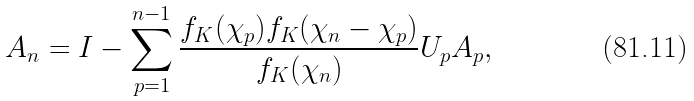Convert formula to latex. <formula><loc_0><loc_0><loc_500><loc_500>A _ { n } = I - \sum _ { p = 1 } ^ { n - 1 } \frac { f _ { K } ( \chi _ { p } ) f _ { K } ( \chi _ { n } - \chi _ { p } ) } { f _ { K } ( \chi _ { n } ) } U _ { p } A _ { p } ,</formula> 